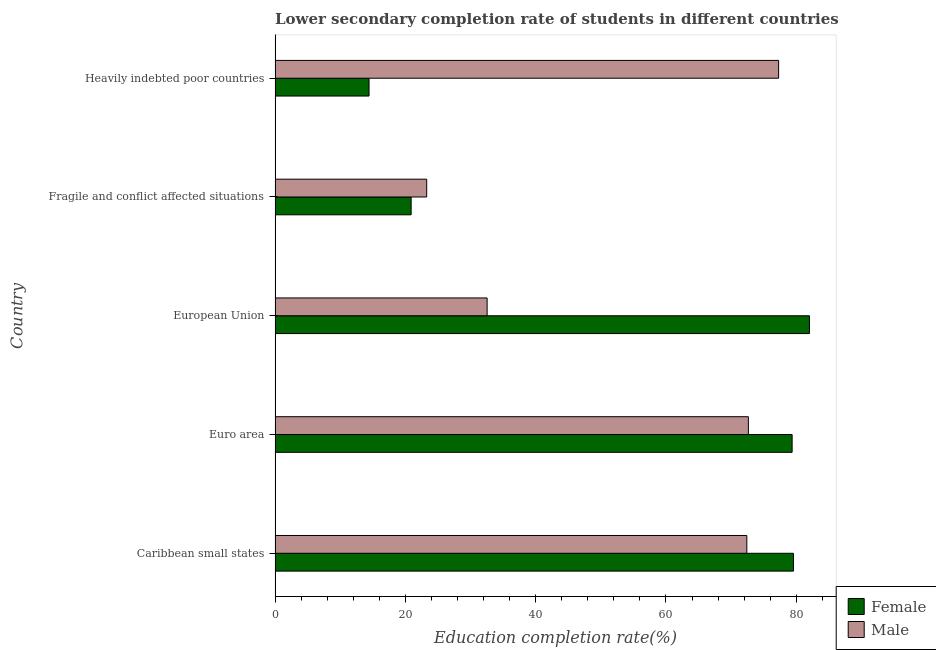How many different coloured bars are there?
Ensure brevity in your answer.  2. Are the number of bars per tick equal to the number of legend labels?
Keep it short and to the point. Yes. How many bars are there on the 3rd tick from the bottom?
Your response must be concise. 2. What is the label of the 2nd group of bars from the top?
Make the answer very short. Fragile and conflict affected situations. What is the education completion rate of female students in Fragile and conflict affected situations?
Provide a succinct answer. 20.88. Across all countries, what is the maximum education completion rate of female students?
Keep it short and to the point. 82.03. Across all countries, what is the minimum education completion rate of female students?
Make the answer very short. 14.42. In which country was the education completion rate of female students maximum?
Keep it short and to the point. European Union. In which country was the education completion rate of male students minimum?
Ensure brevity in your answer.  Fragile and conflict affected situations. What is the total education completion rate of male students in the graph?
Your answer should be very brief. 278.17. What is the difference between the education completion rate of female students in European Union and that in Fragile and conflict affected situations?
Ensure brevity in your answer.  61.14. What is the difference between the education completion rate of female students in Euro area and the education completion rate of male students in European Union?
Your response must be concise. 46.82. What is the average education completion rate of female students per country?
Provide a short and direct response. 55.25. What is the difference between the education completion rate of male students and education completion rate of female students in Heavily indebted poor countries?
Make the answer very short. 62.87. In how many countries, is the education completion rate of female students greater than 16 %?
Your answer should be compact. 4. What is the ratio of the education completion rate of male students in European Union to that in Fragile and conflict affected situations?
Keep it short and to the point. 1.4. Is the difference between the education completion rate of male students in Fragile and conflict affected situations and Heavily indebted poor countries greater than the difference between the education completion rate of female students in Fragile and conflict affected situations and Heavily indebted poor countries?
Provide a short and direct response. No. What is the difference between the highest and the second highest education completion rate of female students?
Offer a terse response. 2.46. What is the difference between the highest and the lowest education completion rate of male students?
Offer a terse response. 54.02. Is the sum of the education completion rate of female students in Euro area and European Union greater than the maximum education completion rate of male students across all countries?
Offer a terse response. Yes. What does the 2nd bar from the top in Heavily indebted poor countries represents?
Your response must be concise. Female. What is the difference between two consecutive major ticks on the X-axis?
Provide a succinct answer. 20. Are the values on the major ticks of X-axis written in scientific E-notation?
Your answer should be very brief. No. Does the graph contain any zero values?
Provide a short and direct response. No. Does the graph contain grids?
Give a very brief answer. No. Where does the legend appear in the graph?
Provide a succinct answer. Bottom right. How many legend labels are there?
Provide a succinct answer. 2. What is the title of the graph?
Your response must be concise. Lower secondary completion rate of students in different countries. Does "Boys" appear as one of the legend labels in the graph?
Offer a very short reply. No. What is the label or title of the X-axis?
Give a very brief answer. Education completion rate(%). What is the Education completion rate(%) in Female in Caribbean small states?
Offer a very short reply. 79.57. What is the Education completion rate(%) in Male in Caribbean small states?
Keep it short and to the point. 72.41. What is the Education completion rate(%) in Female in Euro area?
Offer a very short reply. 79.37. What is the Education completion rate(%) in Male in Euro area?
Your answer should be very brief. 72.65. What is the Education completion rate(%) in Female in European Union?
Keep it short and to the point. 82.03. What is the Education completion rate(%) in Male in European Union?
Make the answer very short. 32.55. What is the Education completion rate(%) of Female in Fragile and conflict affected situations?
Your answer should be compact. 20.88. What is the Education completion rate(%) in Male in Fragile and conflict affected situations?
Provide a succinct answer. 23.27. What is the Education completion rate(%) of Female in Heavily indebted poor countries?
Ensure brevity in your answer.  14.42. What is the Education completion rate(%) of Male in Heavily indebted poor countries?
Your response must be concise. 77.29. Across all countries, what is the maximum Education completion rate(%) of Female?
Your response must be concise. 82.03. Across all countries, what is the maximum Education completion rate(%) of Male?
Give a very brief answer. 77.29. Across all countries, what is the minimum Education completion rate(%) in Female?
Give a very brief answer. 14.42. Across all countries, what is the minimum Education completion rate(%) of Male?
Give a very brief answer. 23.27. What is the total Education completion rate(%) in Female in the graph?
Your answer should be very brief. 276.27. What is the total Education completion rate(%) of Male in the graph?
Ensure brevity in your answer.  278.17. What is the difference between the Education completion rate(%) of Female in Caribbean small states and that in Euro area?
Your answer should be compact. 0.2. What is the difference between the Education completion rate(%) in Male in Caribbean small states and that in Euro area?
Your answer should be compact. -0.24. What is the difference between the Education completion rate(%) of Female in Caribbean small states and that in European Union?
Your answer should be very brief. -2.46. What is the difference between the Education completion rate(%) of Male in Caribbean small states and that in European Union?
Give a very brief answer. 39.86. What is the difference between the Education completion rate(%) of Female in Caribbean small states and that in Fragile and conflict affected situations?
Your answer should be compact. 58.69. What is the difference between the Education completion rate(%) of Male in Caribbean small states and that in Fragile and conflict affected situations?
Offer a terse response. 49.14. What is the difference between the Education completion rate(%) in Female in Caribbean small states and that in Heavily indebted poor countries?
Your answer should be very brief. 65.15. What is the difference between the Education completion rate(%) in Male in Caribbean small states and that in Heavily indebted poor countries?
Your answer should be compact. -4.88. What is the difference between the Education completion rate(%) of Female in Euro area and that in European Union?
Your answer should be compact. -2.66. What is the difference between the Education completion rate(%) of Male in Euro area and that in European Union?
Offer a terse response. 40.1. What is the difference between the Education completion rate(%) of Female in Euro area and that in Fragile and conflict affected situations?
Your answer should be very brief. 58.48. What is the difference between the Education completion rate(%) in Male in Euro area and that in Fragile and conflict affected situations?
Give a very brief answer. 49.37. What is the difference between the Education completion rate(%) in Female in Euro area and that in Heavily indebted poor countries?
Ensure brevity in your answer.  64.94. What is the difference between the Education completion rate(%) in Male in Euro area and that in Heavily indebted poor countries?
Keep it short and to the point. -4.64. What is the difference between the Education completion rate(%) in Female in European Union and that in Fragile and conflict affected situations?
Ensure brevity in your answer.  61.14. What is the difference between the Education completion rate(%) of Male in European Union and that in Fragile and conflict affected situations?
Ensure brevity in your answer.  9.27. What is the difference between the Education completion rate(%) in Female in European Union and that in Heavily indebted poor countries?
Your answer should be compact. 67.61. What is the difference between the Education completion rate(%) of Male in European Union and that in Heavily indebted poor countries?
Provide a succinct answer. -44.74. What is the difference between the Education completion rate(%) in Female in Fragile and conflict affected situations and that in Heavily indebted poor countries?
Ensure brevity in your answer.  6.46. What is the difference between the Education completion rate(%) of Male in Fragile and conflict affected situations and that in Heavily indebted poor countries?
Provide a short and direct response. -54.02. What is the difference between the Education completion rate(%) of Female in Caribbean small states and the Education completion rate(%) of Male in Euro area?
Make the answer very short. 6.92. What is the difference between the Education completion rate(%) in Female in Caribbean small states and the Education completion rate(%) in Male in European Union?
Offer a very short reply. 47.02. What is the difference between the Education completion rate(%) of Female in Caribbean small states and the Education completion rate(%) of Male in Fragile and conflict affected situations?
Offer a terse response. 56.29. What is the difference between the Education completion rate(%) in Female in Caribbean small states and the Education completion rate(%) in Male in Heavily indebted poor countries?
Offer a terse response. 2.28. What is the difference between the Education completion rate(%) of Female in Euro area and the Education completion rate(%) of Male in European Union?
Make the answer very short. 46.82. What is the difference between the Education completion rate(%) in Female in Euro area and the Education completion rate(%) in Male in Fragile and conflict affected situations?
Ensure brevity in your answer.  56.09. What is the difference between the Education completion rate(%) in Female in Euro area and the Education completion rate(%) in Male in Heavily indebted poor countries?
Your response must be concise. 2.07. What is the difference between the Education completion rate(%) of Female in European Union and the Education completion rate(%) of Male in Fragile and conflict affected situations?
Provide a succinct answer. 58.75. What is the difference between the Education completion rate(%) of Female in European Union and the Education completion rate(%) of Male in Heavily indebted poor countries?
Ensure brevity in your answer.  4.74. What is the difference between the Education completion rate(%) of Female in Fragile and conflict affected situations and the Education completion rate(%) of Male in Heavily indebted poor countries?
Your answer should be very brief. -56.41. What is the average Education completion rate(%) of Female per country?
Your answer should be compact. 55.25. What is the average Education completion rate(%) of Male per country?
Your answer should be very brief. 55.63. What is the difference between the Education completion rate(%) of Female and Education completion rate(%) of Male in Caribbean small states?
Give a very brief answer. 7.16. What is the difference between the Education completion rate(%) of Female and Education completion rate(%) of Male in Euro area?
Provide a succinct answer. 6.72. What is the difference between the Education completion rate(%) of Female and Education completion rate(%) of Male in European Union?
Offer a very short reply. 49.48. What is the difference between the Education completion rate(%) of Female and Education completion rate(%) of Male in Fragile and conflict affected situations?
Provide a succinct answer. -2.39. What is the difference between the Education completion rate(%) in Female and Education completion rate(%) in Male in Heavily indebted poor countries?
Make the answer very short. -62.87. What is the ratio of the Education completion rate(%) in Female in Caribbean small states to that in European Union?
Your answer should be very brief. 0.97. What is the ratio of the Education completion rate(%) in Male in Caribbean small states to that in European Union?
Offer a terse response. 2.22. What is the ratio of the Education completion rate(%) in Female in Caribbean small states to that in Fragile and conflict affected situations?
Offer a terse response. 3.81. What is the ratio of the Education completion rate(%) of Male in Caribbean small states to that in Fragile and conflict affected situations?
Provide a short and direct response. 3.11. What is the ratio of the Education completion rate(%) of Female in Caribbean small states to that in Heavily indebted poor countries?
Offer a terse response. 5.52. What is the ratio of the Education completion rate(%) of Male in Caribbean small states to that in Heavily indebted poor countries?
Make the answer very short. 0.94. What is the ratio of the Education completion rate(%) in Female in Euro area to that in European Union?
Offer a very short reply. 0.97. What is the ratio of the Education completion rate(%) in Male in Euro area to that in European Union?
Ensure brevity in your answer.  2.23. What is the ratio of the Education completion rate(%) of Female in Euro area to that in Fragile and conflict affected situations?
Make the answer very short. 3.8. What is the ratio of the Education completion rate(%) of Male in Euro area to that in Fragile and conflict affected situations?
Make the answer very short. 3.12. What is the ratio of the Education completion rate(%) of Female in Euro area to that in Heavily indebted poor countries?
Keep it short and to the point. 5.5. What is the ratio of the Education completion rate(%) in Male in Euro area to that in Heavily indebted poor countries?
Offer a very short reply. 0.94. What is the ratio of the Education completion rate(%) in Female in European Union to that in Fragile and conflict affected situations?
Offer a very short reply. 3.93. What is the ratio of the Education completion rate(%) in Male in European Union to that in Fragile and conflict affected situations?
Provide a succinct answer. 1.4. What is the ratio of the Education completion rate(%) in Female in European Union to that in Heavily indebted poor countries?
Offer a terse response. 5.69. What is the ratio of the Education completion rate(%) of Male in European Union to that in Heavily indebted poor countries?
Offer a terse response. 0.42. What is the ratio of the Education completion rate(%) in Female in Fragile and conflict affected situations to that in Heavily indebted poor countries?
Your answer should be compact. 1.45. What is the ratio of the Education completion rate(%) in Male in Fragile and conflict affected situations to that in Heavily indebted poor countries?
Make the answer very short. 0.3. What is the difference between the highest and the second highest Education completion rate(%) in Female?
Provide a short and direct response. 2.46. What is the difference between the highest and the second highest Education completion rate(%) in Male?
Ensure brevity in your answer.  4.64. What is the difference between the highest and the lowest Education completion rate(%) in Female?
Make the answer very short. 67.61. What is the difference between the highest and the lowest Education completion rate(%) of Male?
Give a very brief answer. 54.02. 